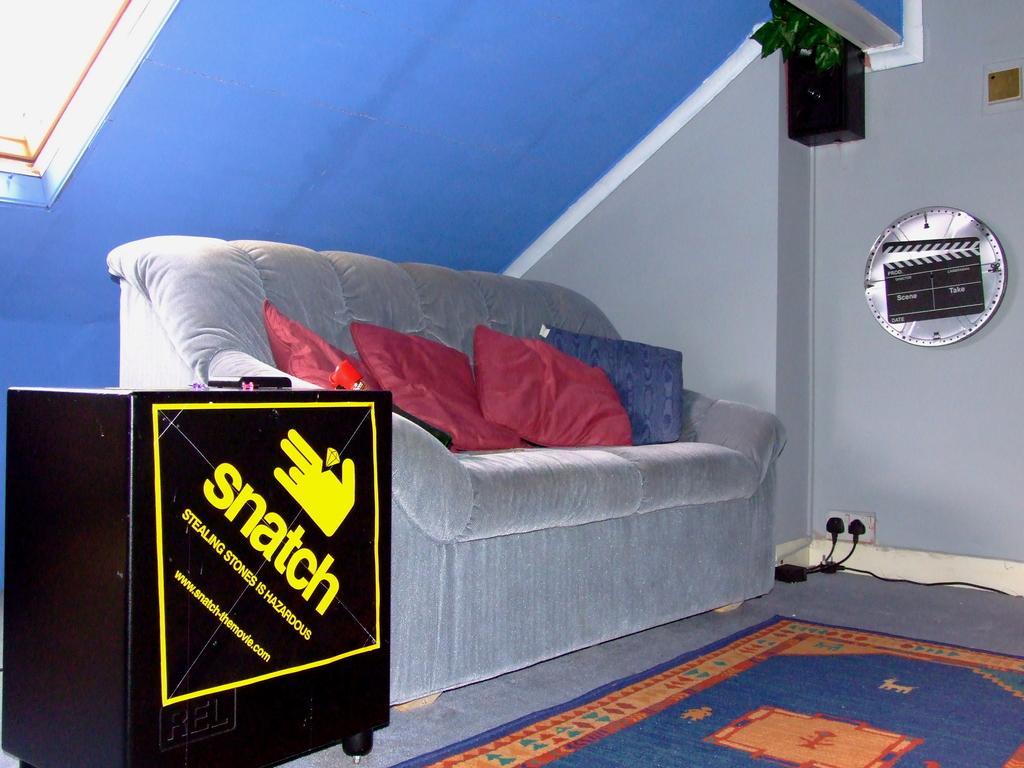In one or two sentences, can you explain what this image depicts? This is inside of the room we can see sofa,furniture,mat on the floor,on the sofa there are pillows. On the background we can see wall,ring disk,speaker. 